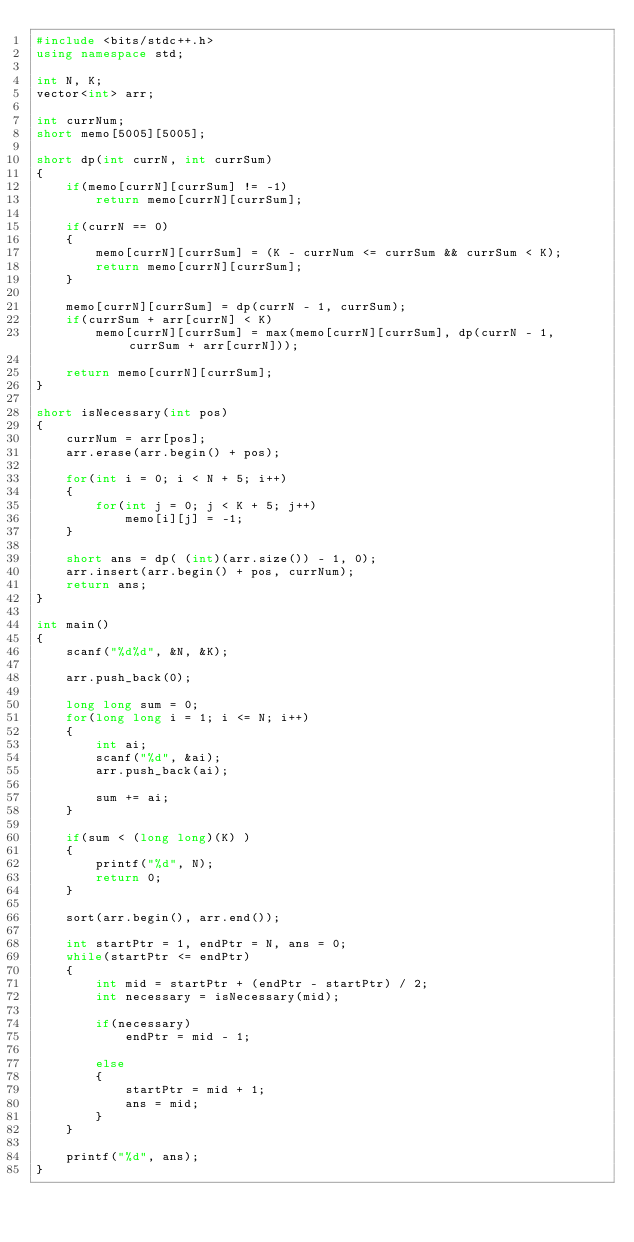<code> <loc_0><loc_0><loc_500><loc_500><_C++_>#include <bits/stdc++.h>
using namespace std;

int N, K;
vector<int> arr;

int currNum;
short memo[5005][5005];

short dp(int currN, int currSum)
{
	if(memo[currN][currSum] != -1)
		return memo[currN][currSum];
		
	if(currN == 0)
	{
		memo[currN][currSum] = (K - currNum <= currSum && currSum < K);
		return memo[currN][currSum];
	}
	
	memo[currN][currSum] = dp(currN - 1, currSum);
	if(currSum + arr[currN] < K)
		memo[currN][currSum] = max(memo[currN][currSum], dp(currN - 1, currSum + arr[currN]));
		
	return memo[currN][currSum];
}

short isNecessary(int pos)
{
	currNum = arr[pos];
	arr.erase(arr.begin() + pos);

	for(int i = 0; i < N + 5; i++)
	{
		for(int j = 0; j < K + 5; j++)
			memo[i][j] = -1;
	}
	
	short ans = dp( (int)(arr.size()) - 1, 0);
	arr.insert(arr.begin() + pos, currNum);
	return ans;
}

int main()
{
	scanf("%d%d", &N, &K);
	
	arr.push_back(0);
	
	long long sum = 0;
	for(long long i = 1; i <= N; i++)
	{
		int ai;
		scanf("%d", &ai);
		arr.push_back(ai);
		
		sum += ai;
	}
	
	if(sum < (long long)(K) )
	{
		printf("%d", N);
		return 0;
	}
	
	sort(arr.begin(), arr.end());
	
	int startPtr = 1, endPtr = N, ans = 0;
	while(startPtr <= endPtr)
	{
		int mid = startPtr + (endPtr - startPtr) / 2;
		int necessary = isNecessary(mid);

		if(necessary)
			endPtr = mid - 1;
			
		else
		{
			startPtr = mid + 1;
			ans = mid;
		}
	}
	
	printf("%d", ans);
}
</code> 